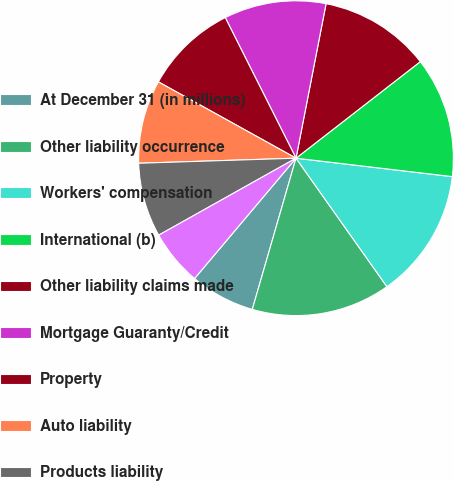Convert chart. <chart><loc_0><loc_0><loc_500><loc_500><pie_chart><fcel>At December 31 (in millions)<fcel>Other liability occurrence<fcel>Workers' compensation<fcel>International (b)<fcel>Other liability claims made<fcel>Mortgage Guaranty/Credit<fcel>Property<fcel>Auto liability<fcel>Products liability<fcel>Medical malpractice<nl><fcel>6.67%<fcel>14.28%<fcel>13.33%<fcel>12.38%<fcel>11.43%<fcel>10.48%<fcel>9.52%<fcel>8.57%<fcel>7.62%<fcel>5.72%<nl></chart> 